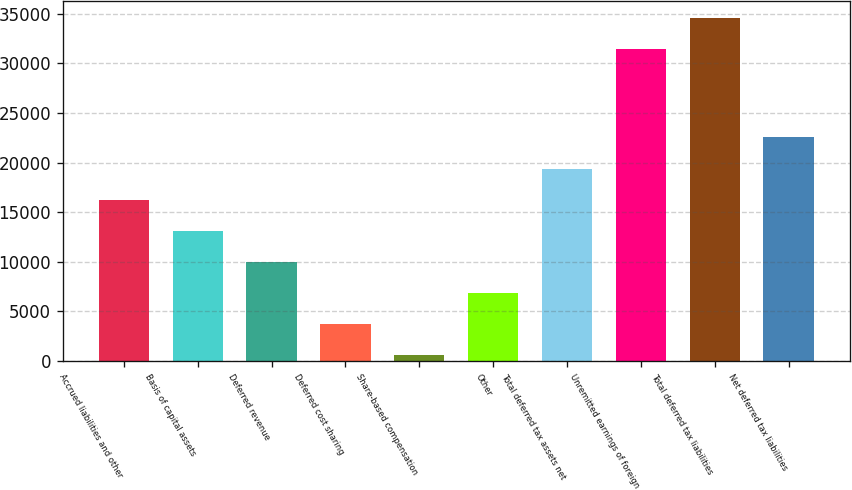<chart> <loc_0><loc_0><loc_500><loc_500><bar_chart><fcel>Accrued liabilities and other<fcel>Basis of capital assets<fcel>Deferred revenue<fcel>Deferred cost sharing<fcel>Share-based compensation<fcel>Other<fcel>Total deferred tax assets net<fcel>Unremitted earnings of foreign<fcel>Total deferred tax liabilities<fcel>Net deferred tax liabilities<nl><fcel>16261<fcel>13129<fcel>9997<fcel>3733<fcel>601<fcel>6865<fcel>19393<fcel>31436<fcel>34568<fcel>22525<nl></chart> 